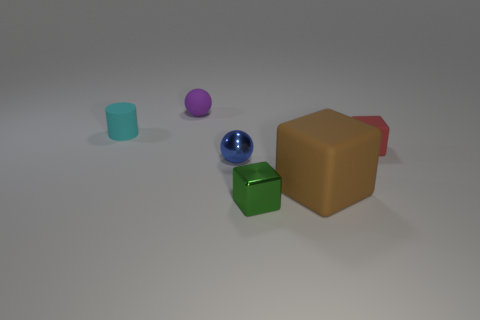There is a red matte cube; is its size the same as the green shiny cube that is in front of the brown thing?
Your answer should be very brief. Yes. How many cylinders are either purple objects or brown things?
Give a very brief answer. 0. There is a brown object that is made of the same material as the tiny red thing; what size is it?
Make the answer very short. Large. Is the size of the matte block that is behind the large rubber block the same as the cube that is in front of the big rubber object?
Your response must be concise. Yes. What number of things are either tiny blue metal balls or matte cylinders?
Make the answer very short. 2. The tiny green metal thing has what shape?
Your answer should be compact. Cube. There is a red thing that is the same shape as the green metal object; what size is it?
Your response must be concise. Small. Are there any other things that have the same material as the small red cube?
Ensure brevity in your answer.  Yes. How big is the ball in front of the tiny ball behind the small cyan thing?
Give a very brief answer. Small. Are there the same number of small cyan rubber cylinders in front of the green shiny thing and large yellow blocks?
Make the answer very short. Yes. 